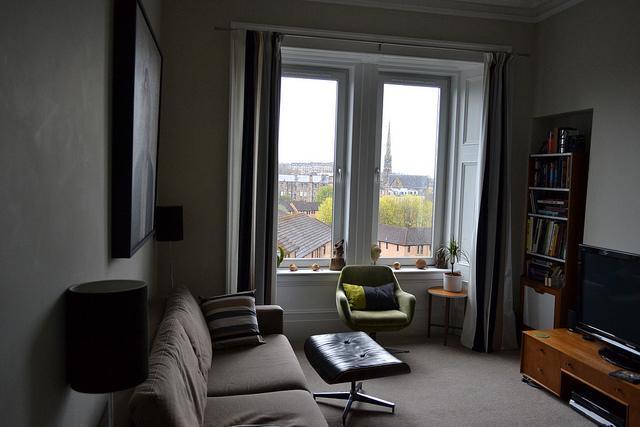What color is the left side of the pillow sitting on the single seat?
From the following set of four choices, select the accurate answer to respond to the question.
Options: Black, yellow, white, orange. Yellow. 